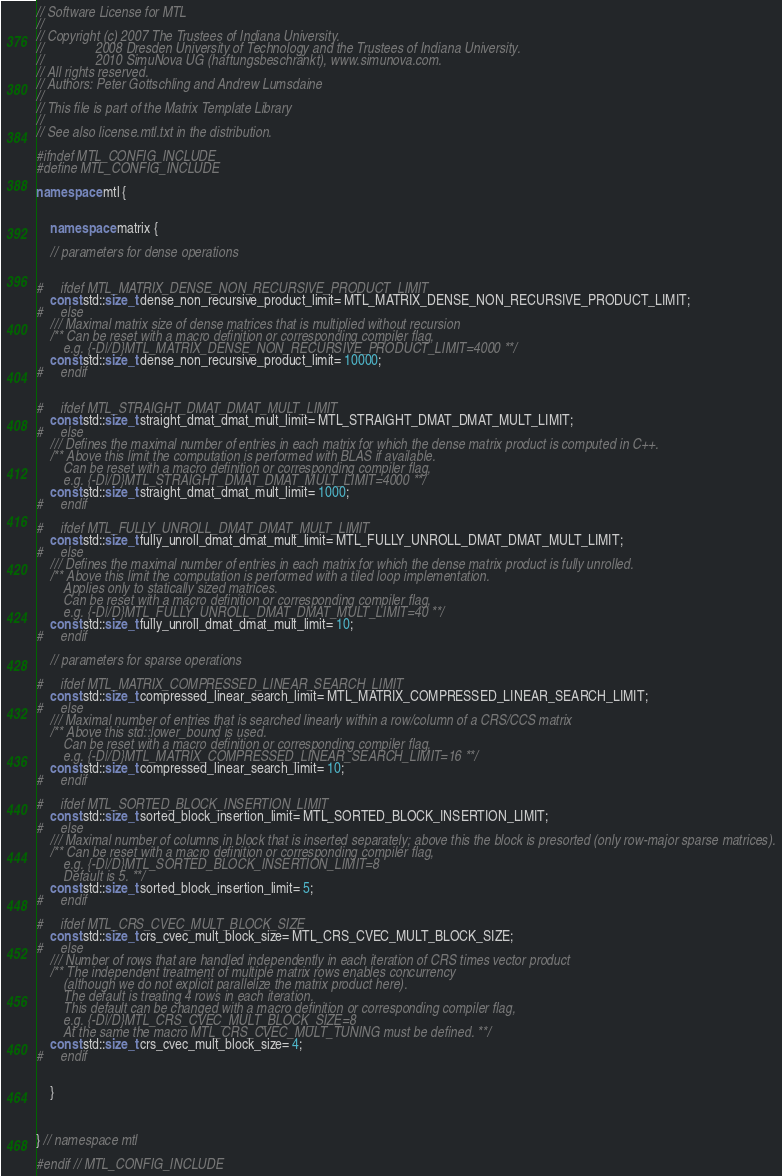<code> <loc_0><loc_0><loc_500><loc_500><_C++_>// Software License for MTL
// 
// Copyright (c) 2007 The Trustees of Indiana University. 
//               2008 Dresden University of Technology and the Trustees of Indiana University.
//               2010 SimuNova UG (haftungsbeschränkt), www.simunova.com. 
// All rights reserved.
// Authors: Peter Gottschling and Andrew Lumsdaine
// 
// This file is part of the Matrix Template Library
// 
// See also license.mtl.txt in the distribution.

#ifndef MTL_CONFIG_INCLUDE
#define MTL_CONFIG_INCLUDE

namespace mtl {


    namespace matrix {

	// parameters for dense operations


#     ifdef MTL_MATRIX_DENSE_NON_RECURSIVE_PRODUCT_LIMIT
	const std::size_t dense_non_recursive_product_limit= MTL_MATRIX_DENSE_NON_RECURSIVE_PRODUCT_LIMIT;
#     else
	/// Maximal matrix size of dense matrices that is multiplied without recursion
	/** Can be reset with a macro definition or corresponding compiler flag,
	    e.g. {-D|/D}MTL_MATRIX_DENSE_NON_RECURSIVE_PRODUCT_LIMIT=4000 **/
	const std::size_t dense_non_recursive_product_limit= 10000;
#     endif


#     ifdef MTL_STRAIGHT_DMAT_DMAT_MULT_LIMIT
	const std::size_t straight_dmat_dmat_mult_limit= MTL_STRAIGHT_DMAT_DMAT_MULT_LIMIT;
#     else
	/// Defines the maximal number of entries in each matrix for which the dense matrix product is computed in C++.
	/** Above this limit the computation is performed with BLAS if available.
	    Can be reset with a macro definition or corresponding compiler flag,
	    e.g. {-D|/D}MTL_STRAIGHT_DMAT_DMAT_MULT_LIMIT=4000 **/
	const std::size_t straight_dmat_dmat_mult_limit= 1000;
#     endif

#     ifdef MTL_FULLY_UNROLL_DMAT_DMAT_MULT_LIMIT
	const std::size_t fully_unroll_dmat_dmat_mult_limit= MTL_FULLY_UNROLL_DMAT_DMAT_MULT_LIMIT;
#     else
	/// Defines the maximal number of entries in each matrix for which the dense matrix product is fully unrolled.
	/** Above this limit the computation is performed with a tiled loop implementation.
	    Applies only to statically sized matrices.
	    Can be reset with a macro definition or corresponding compiler flag,
	    e.g. {-D|/D}MTL_FULLY_UNROLL_DMAT_DMAT_MULT_LIMIT=40 **/
	const std::size_t fully_unroll_dmat_dmat_mult_limit= 10;
#     endif

	// parameters for sparse operations

#     ifdef MTL_MATRIX_COMPRESSED_LINEAR_SEARCH_LIMIT
	const std::size_t compressed_linear_search_limit= MTL_MATRIX_COMPRESSED_LINEAR_SEARCH_LIMIT;
#     else
	/// Maximal number of entries that is searched linearly within a row/column of a CRS/CCS matrix
	/** Above this std::lower_bound is used.
	    Can be reset with a macro definition or corresponding compiler flag,
	    e.g. {-D|/D}MTL_MATRIX_COMPRESSED_LINEAR_SEARCH_LIMIT=16 **/
	const std::size_t compressed_linear_search_limit= 10;
#     endif

#     ifdef MTL_SORTED_BLOCK_INSERTION_LIMIT
	const std::size_t sorted_block_insertion_limit= MTL_SORTED_BLOCK_INSERTION_LIMIT;
#     else
	/// Maximal number of columns in block that is inserted separately; above this the block is presorted (only row-major sparse matrices).
	/** Can be reset with a macro definition or corresponding compiler flag,
	    e.g. {-D|/D}MTL_SORTED_BLOCK_INSERTION_LIMIT=8 
	    Default is 5. **/
	const std::size_t sorted_block_insertion_limit= 5;
#     endif

#     ifdef MTL_CRS_CVEC_MULT_BLOCK_SIZE
	const std::size_t crs_cvec_mult_block_size= MTL_CRS_CVEC_MULT_BLOCK_SIZE;
#     else
	/// Number of rows that are handled independently in each iteration of CRS times vector product 
	/** The independent treatment of multiple matrix rows enables concurrency 
	    (although we do not explicit parallelize the matrix product here).
	    The default is treating 4 rows in each iteration.
	    This default can be changed with a macro definition or corresponding compiler flag,
	    e.g. {-D|/D}MTL_CRS_CVEC_MULT_BLOCK_SIZE=8
	    At the same the macro MTL_CRS_CVEC_MULT_TUNING must be defined. **/
	const std::size_t crs_cvec_mult_block_size= 4;
#     endif


    }



} // namespace mtl

#endif // MTL_CONFIG_INCLUDE
</code> 